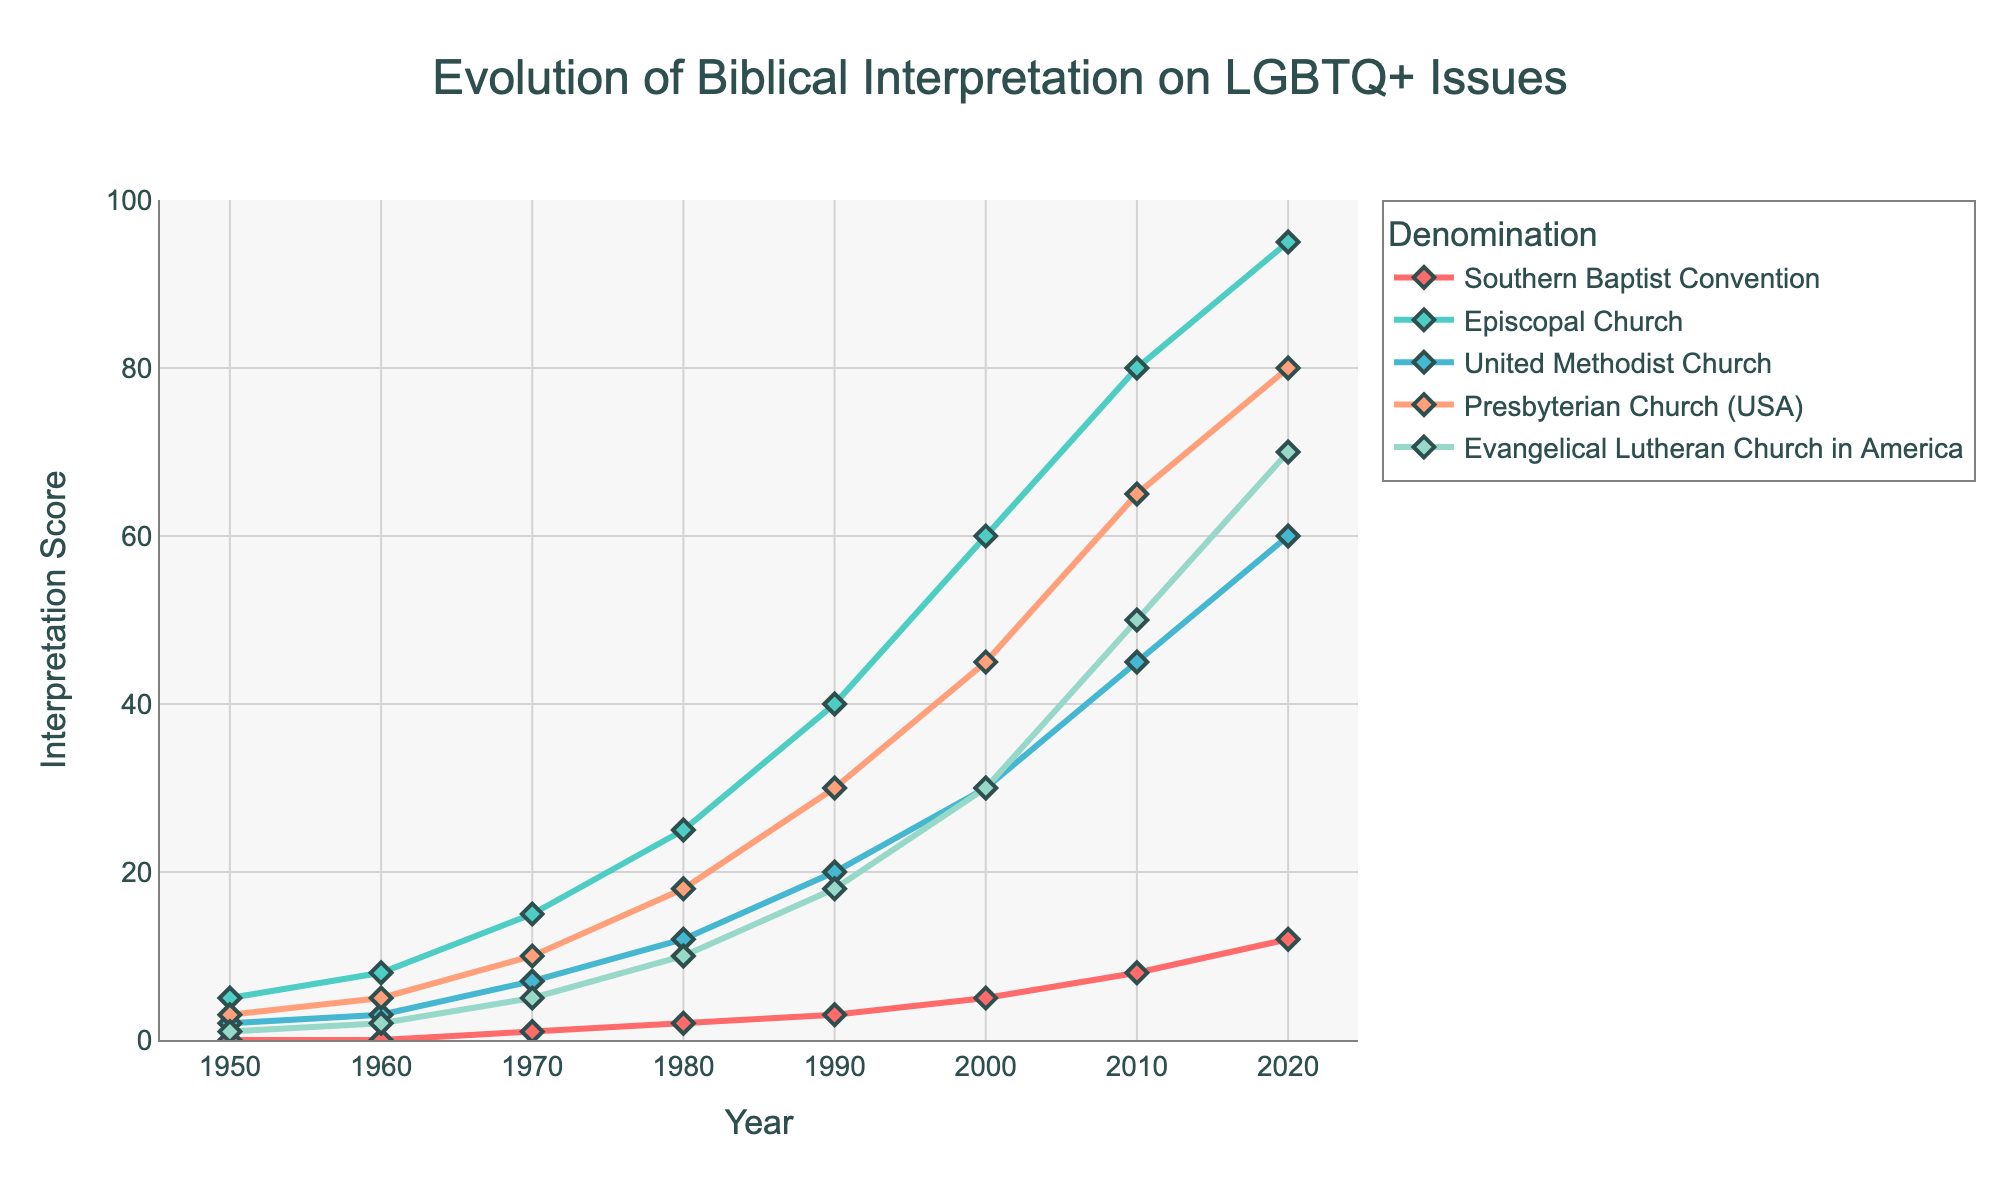What is the highest interpretation score reached by the Episcopal Church? To find the highest interpretation score for the Episcopal Church, look at the peak value reached by the corresponding line. The highest point on the Episcopal Church's line is 95 in 2020.
Answer: 95 Which denomination had the lowest interpretation score in 1990? In 1990, compare the interpretation scores of all denominations. Southern Baptist Convention had the lowest score, which is 3.
Answer: Southern Baptist Convention How many more points did the United Methodist Church score than the Southern Baptist Convention in 2020? Subtract the interpretation score of the Southern Baptist Convention from that of the United Methodist Church for the year 2020. The scores are 60 - 12 = 48.
Answer: 48 What is the difference in interpretation score between the Evangelical Lutheran Church in America and the Presbyterian Church (USA) in 2000? Look at the interpretation scores for both denominations in the year 2000 and subtract the score of the Presbyterian Church (USA) from the score of Evangelical Lutheran Church in America. The difference is 30 - 45 = -15.
Answer: -15 Which denomination showed the most significant increase in interpretation score between 1950 and 2020? Calculate the interpretation score change for each denomination from 1950 to 2020. The Episcopal Church had the largest increase (95 - 5 = 90).
Answer: Episcopal Church What was the average interpretation score for the Episcopal Church from 1950 to 2020? Sum the interpretation scores for the Episcopal Church across all years and divide by the number of data points. (5+8+15+25+40+60+80+95)/8 = 40.
Answer: 40 In which year did the Southern Baptist Convention have the same interpretation score that the United Methodist Church had in 1970? Identify the interpretation score for the United Methodist Church in 1970, which is 7. Then, find the year in the Southern Baptist Convention's data when the score was 7. Southern Baptist Convention did not have this score in any year, so the answer is none.
Answer: None What trend can you observe in the interpretation scores of all denominations from 1950 to 2020? All denominations show an upward trend in interpretation scores from 1950 to 2020, indicating a general increase in inclusivity over time.
Answer: Upward trend Which denomination had the steepest increase in interpretation score between 1990 and 2000? Calculate the rate of change for each denomination between 1990 and 2000. The Episcopal Church had the steepest increase (60 - 40 = 20 points).
Answer: Episcopal Church 